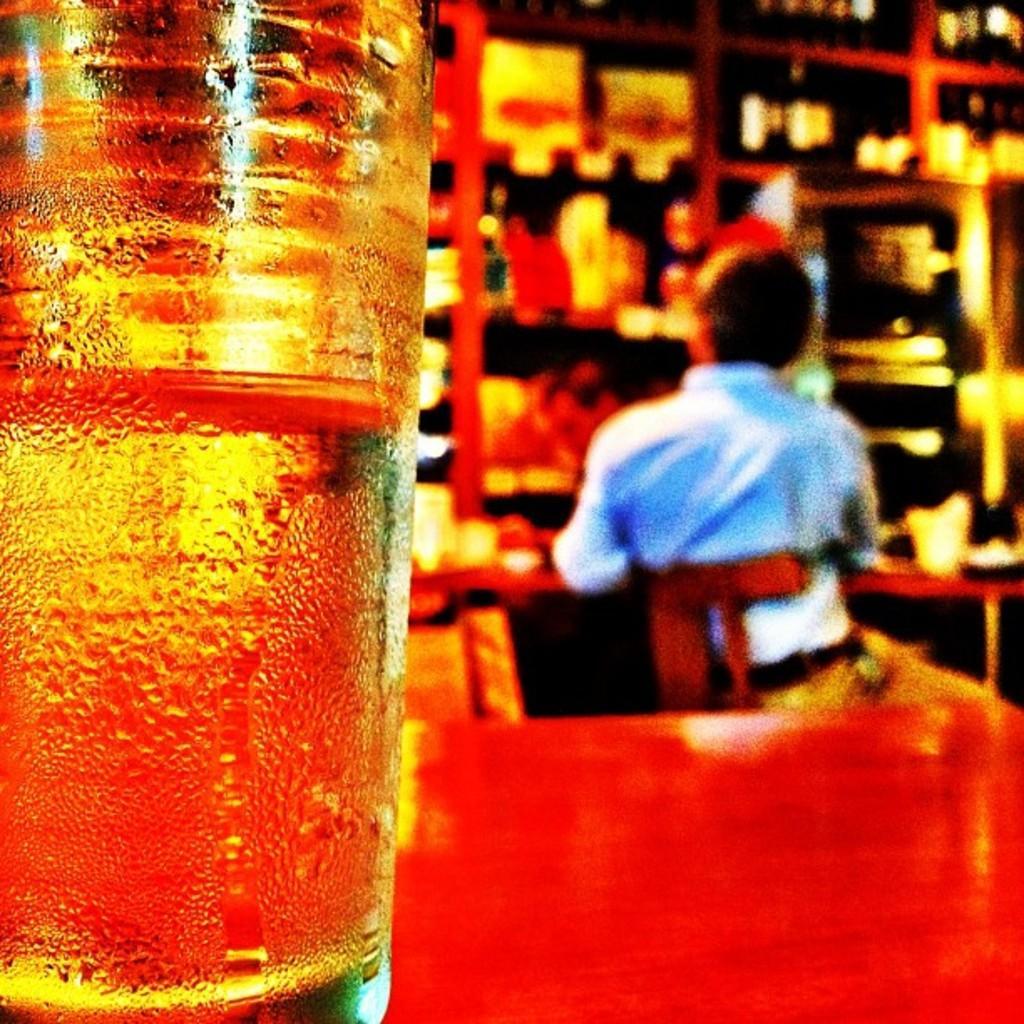How would you summarize this image in a sentence or two? In the foreground of this image, on the table, there is a glass. In the background, there is a man sitting on the chair near a table and we can also see few objects in the rack. 